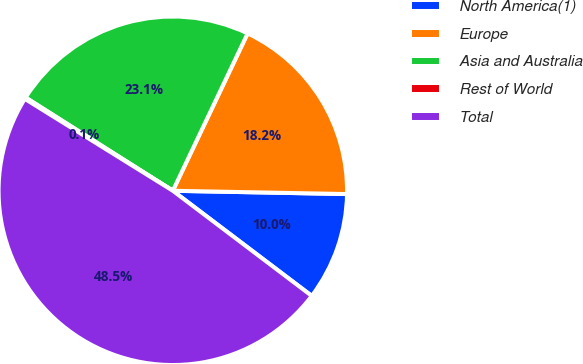Convert chart to OTSL. <chart><loc_0><loc_0><loc_500><loc_500><pie_chart><fcel>North America(1)<fcel>Europe<fcel>Asia and Australia<fcel>Rest of World<fcel>Total<nl><fcel>10.01%<fcel>18.24%<fcel>23.08%<fcel>0.14%<fcel>48.54%<nl></chart> 